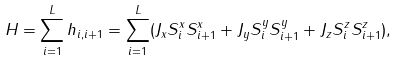Convert formula to latex. <formula><loc_0><loc_0><loc_500><loc_500>H = \sum _ { i = 1 } ^ { L } h _ { i , i + 1 } = \sum _ { i = 1 } ^ { L } ( J _ { x } S _ { i } ^ { x } S _ { i + 1 } ^ { x } + J _ { y } S _ { i } ^ { y } S _ { i + 1 } ^ { y } + J _ { z } S _ { i } ^ { z } S _ { i + 1 } ^ { z } ) ,</formula> 